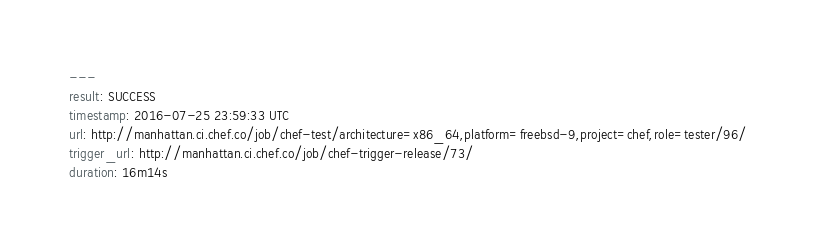<code> <loc_0><loc_0><loc_500><loc_500><_YAML_>---
result: SUCCESS
timestamp: 2016-07-25 23:59:33 UTC
url: http://manhattan.ci.chef.co/job/chef-test/architecture=x86_64,platform=freebsd-9,project=chef,role=tester/96/
trigger_url: http://manhattan.ci.chef.co/job/chef-trigger-release/73/
duration: 16m14s
</code> 